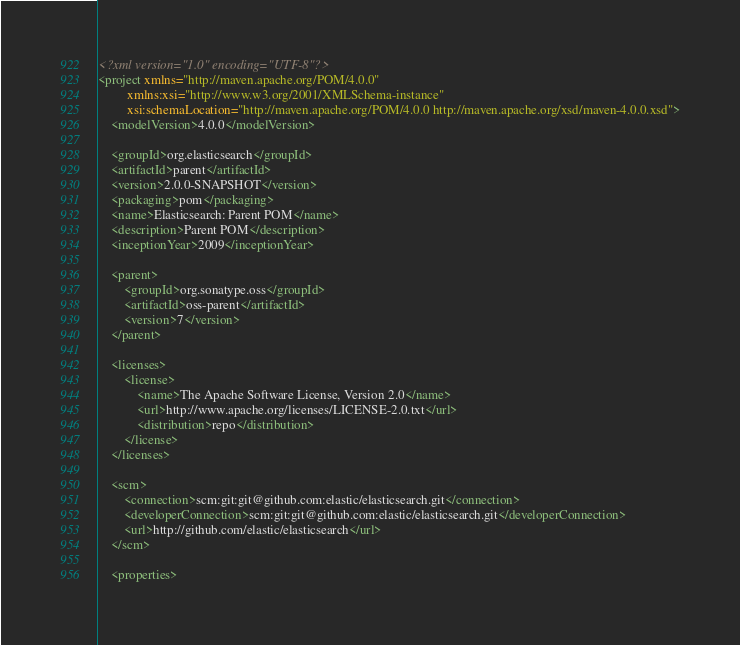<code> <loc_0><loc_0><loc_500><loc_500><_XML_><?xml version="1.0" encoding="UTF-8"?>
<project xmlns="http://maven.apache.org/POM/4.0.0"
         xmlns:xsi="http://www.w3.org/2001/XMLSchema-instance"
         xsi:schemaLocation="http://maven.apache.org/POM/4.0.0 http://maven.apache.org/xsd/maven-4.0.0.xsd">
    <modelVersion>4.0.0</modelVersion>

    <groupId>org.elasticsearch</groupId>
    <artifactId>parent</artifactId>
    <version>2.0.0-SNAPSHOT</version>
    <packaging>pom</packaging>
    <name>Elasticsearch: Parent POM</name>
    <description>Parent POM</description>
    <inceptionYear>2009</inceptionYear>

    <parent>
        <groupId>org.sonatype.oss</groupId>
        <artifactId>oss-parent</artifactId>
        <version>7</version>
    </parent>

    <licenses>
        <license>
            <name>The Apache Software License, Version 2.0</name>
            <url>http://www.apache.org/licenses/LICENSE-2.0.txt</url>
            <distribution>repo</distribution>
        </license>
    </licenses>

    <scm>
        <connection>scm:git:git@github.com:elastic/elasticsearch.git</connection>
        <developerConnection>scm:git:git@github.com:elastic/elasticsearch.git</developerConnection>
        <url>http://github.com/elastic/elasticsearch</url>
    </scm>

    <properties></code> 